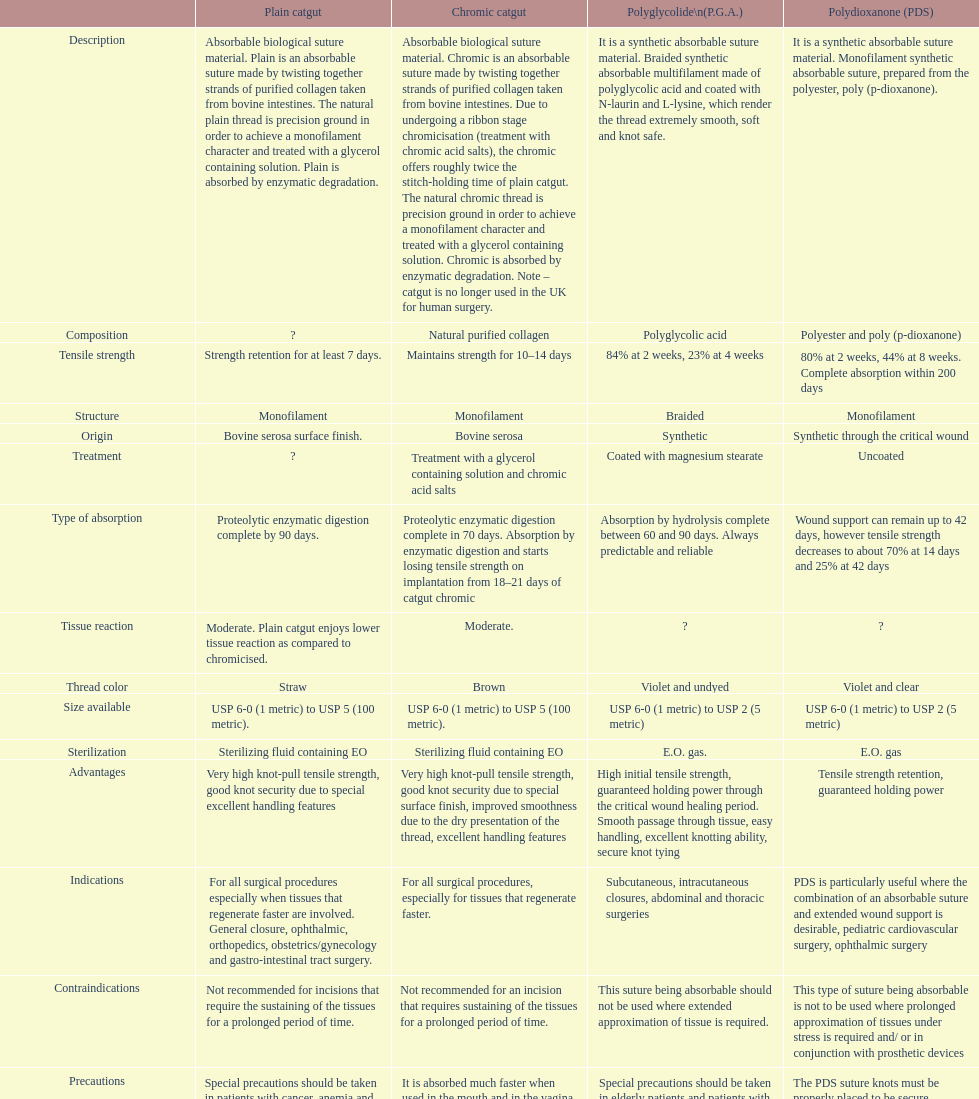Plain catgut and chromic catgut both have what type of structure? Monofilament. 